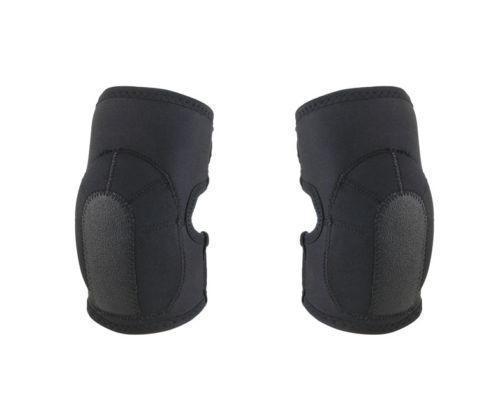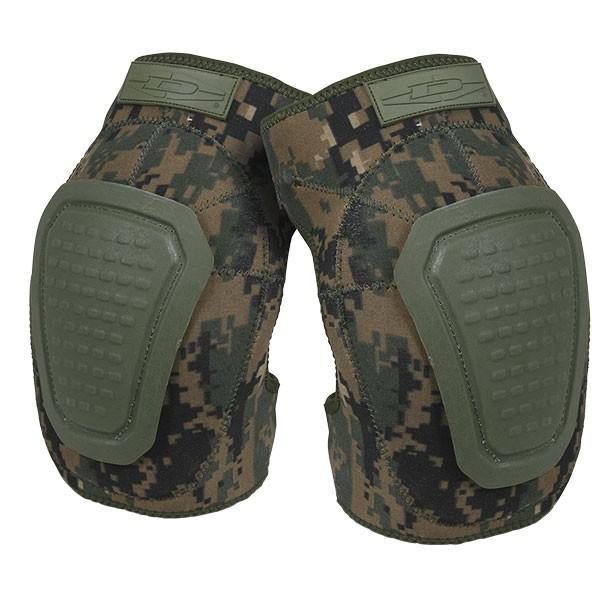The first image is the image on the left, the second image is the image on the right. Given the left and right images, does the statement "At least one set of knee pads is green." hold true? Answer yes or no. Yes. 